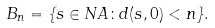<formula> <loc_0><loc_0><loc_500><loc_500>B _ { n } = \{ s \in N A \colon d ( s , 0 ) < n \} .</formula> 